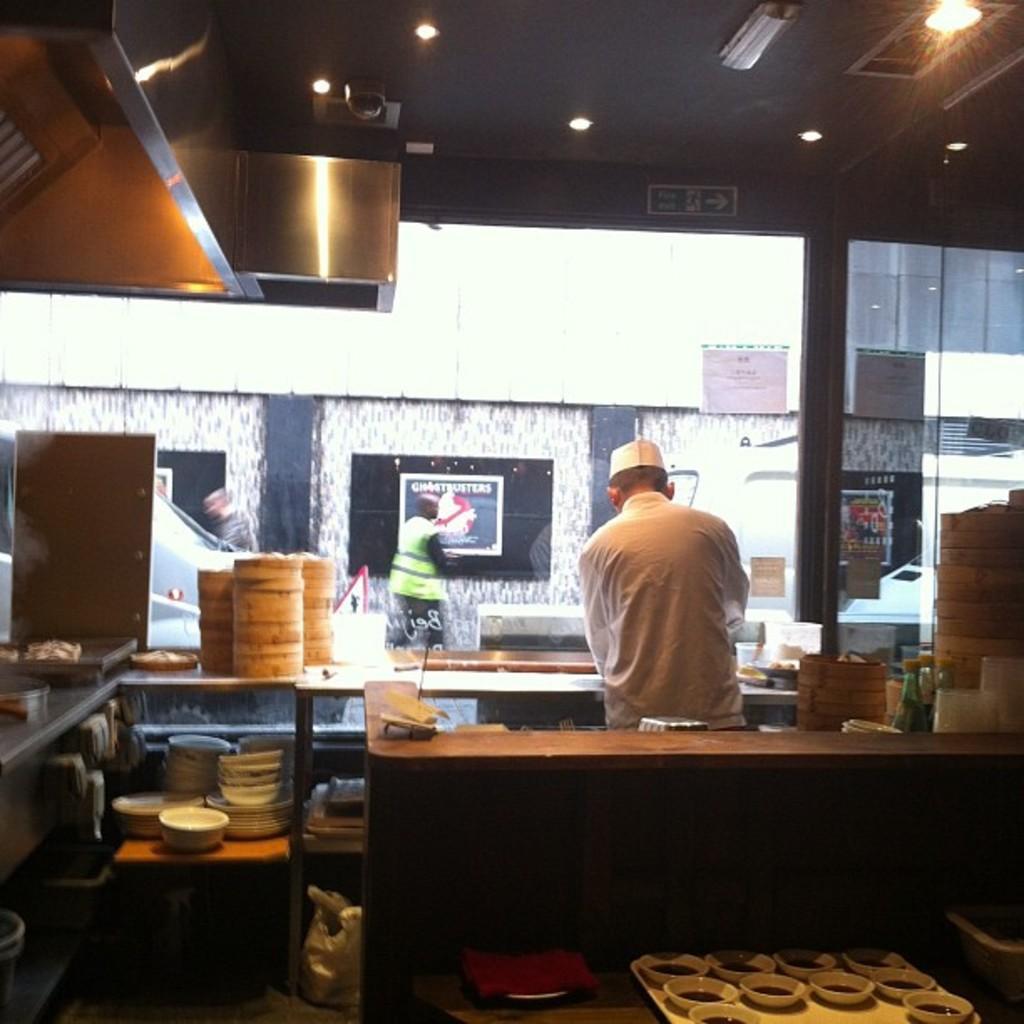Describe this image in one or two sentences. In this picture we can a man and some bowls on the desk and on desk which have some things and there are some lights. 